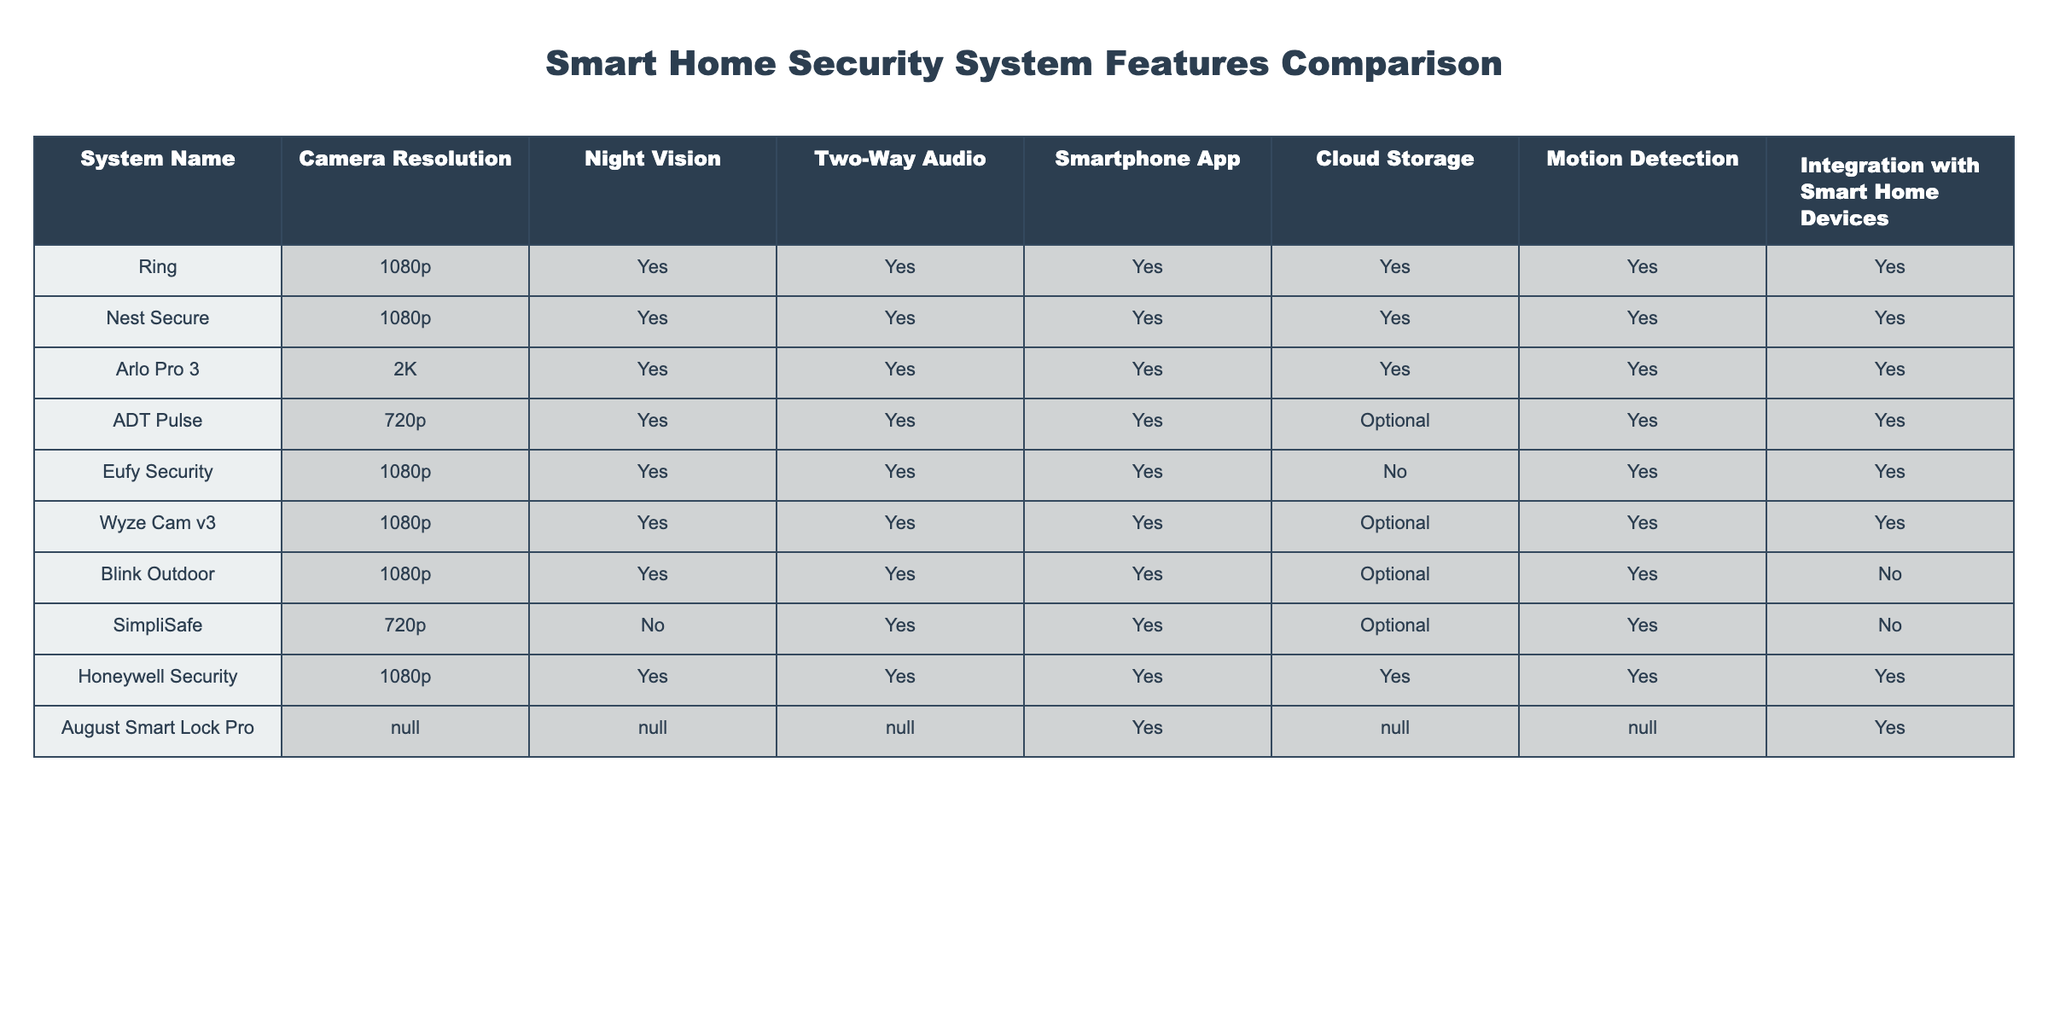What is the camera resolution of the Arlo Pro 3? The table shows that the Arlo Pro 3 has a camera resolution of 2K.
Answer: 2K Which systems offer two-way audio? By reviewing the table, the systems that provide two-way audio are Ring, Nest Secure, Arlo Pro 3, ADT Pulse, Eufy Security, Wyze Cam v3, Blink Outdoor, SimpliSafe, and Honeywell Security.
Answer: Nine systems Is cloud storage available for Eufy Security? The table indicates that Eufy Security does not offer cloud storage, as it specifically states "No" in that column.
Answer: No Which systems have a higher resolution than 720p? The systems with a higher resolution than 720p according to the table are Ring, Nest Secure, Arlo Pro 3, Eufy Security, Wyze Cam v3, and Honeywell Security, since they have 1080p or 2K resolution.
Answer: Six systems Does the August Smart Lock Pro support integration with smart home devices? The table lists the August Smart Lock Pro with "Yes" under integration with smart home devices, indicating it supports this feature.
Answer: Yes Which system has the best camera resolution and also offers motion detection? The Arlo Pro 3 has the best camera resolution at 2K and provides motion detection as indicated.
Answer: Arlo Pro 3 How many systems have optional cloud storage? By looking at the table, three systems (ADT Pulse, Wyze Cam v3, and Blink Outdoor) specify that cloud storage is optional.
Answer: Three systems What is the difference in camera resolution between the Eufy Security and ADT Pulse? Eufy Security has a resolution of 1080p while ADT Pulse has 720p, making the difference 1080p - 720p = 360p.
Answer: 360p Which system does not have night vision? According to the table, SimpliSafe is the only system that does not offer night vision since it is marked as "No."
Answer: SimpliSafe How many systems fully integrate with smart home devices and offer all features? The systems that fully integrate with smart home devices and offer all features (including camera resolution, night vision, two-way audio, and cloud storage) are Ring, Nest Secure, Arlo Pro 3, and Honeywell Security, totaling four systems.
Answer: Four systems 